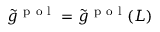<formula> <loc_0><loc_0><loc_500><loc_500>\tilde { g } ^ { p o l } = \tilde { g } ^ { p o l } ( L )</formula> 